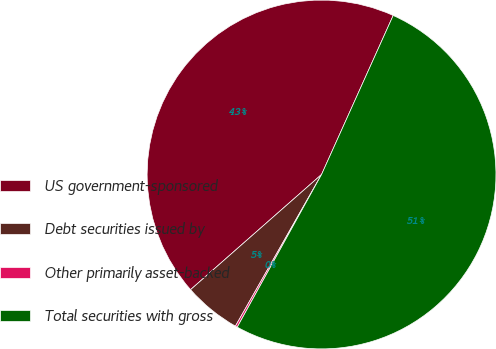Convert chart to OTSL. <chart><loc_0><loc_0><loc_500><loc_500><pie_chart><fcel>US government-sponsored<fcel>Debt securities issued by<fcel>Other primarily asset-backed<fcel>Total securities with gross<nl><fcel>43.22%<fcel>5.3%<fcel>0.19%<fcel>51.3%<nl></chart> 